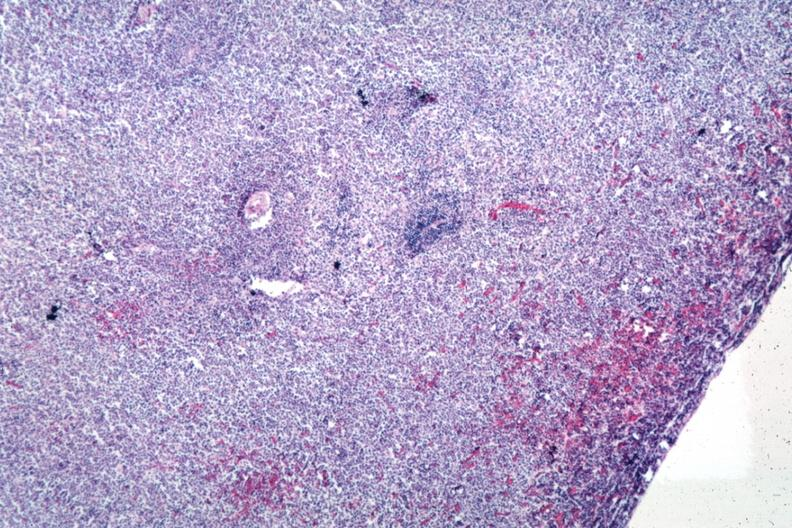s myelomonocytic leukemia present?
Answer the question using a single word or phrase. No 